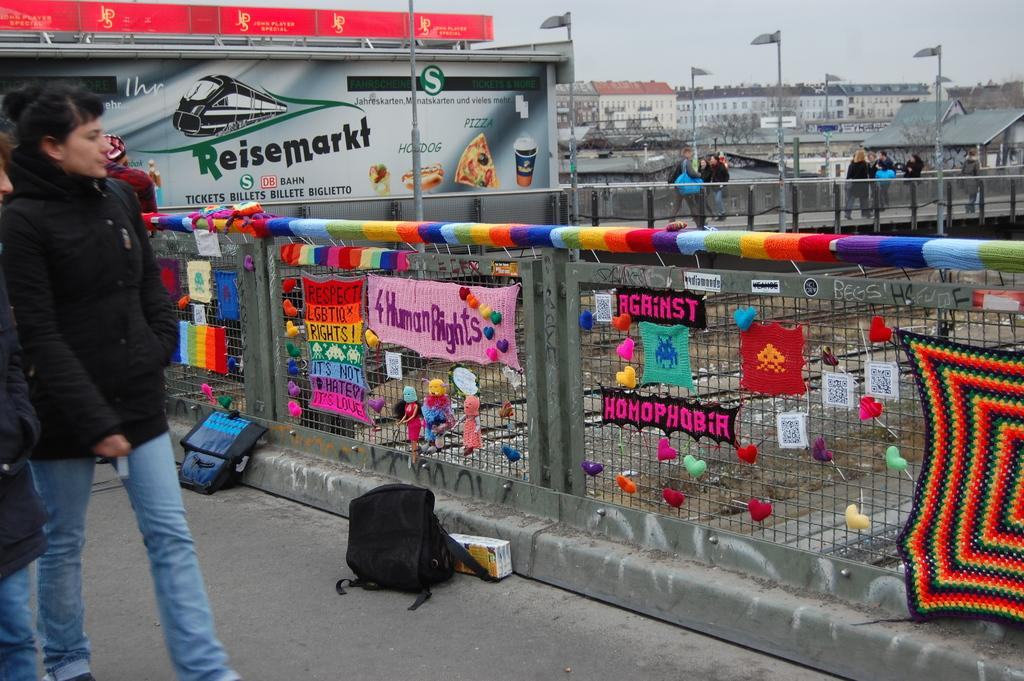What is the main feature of the image? There is a road in the image. What objects can be seen alongside the road? There are bags, a fence, posts, people, poles, hoardings, sheds, and buildings in the image. What is the condition of the sky in the background of the image? The sky is visible in the background of the image. What type of bird can be seen flying over the fuel station in the image? There is no bird or fuel station present in the image. How does the nerve center of the city look like in the image? The image does not depict a nerve center or any specific city infrastructure. 